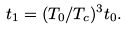<formula> <loc_0><loc_0><loc_500><loc_500>t _ { 1 } = ( T _ { 0 } / T _ { c } ) ^ { 3 } t _ { 0 } .</formula> 